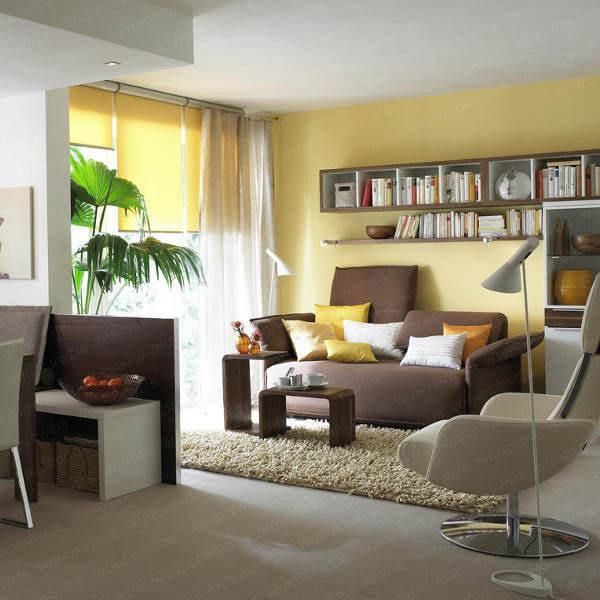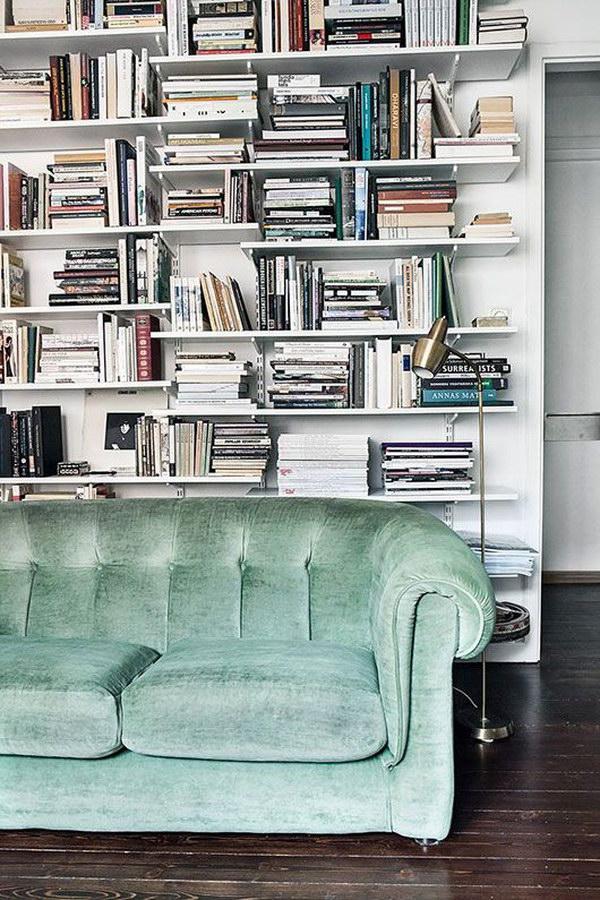The first image is the image on the left, the second image is the image on the right. Assess this claim about the two images: "A bookshelf sits behind a couch in a yellow room in one of the images.". Correct or not? Answer yes or no. Yes. The first image is the image on the left, the second image is the image on the right. For the images shown, is this caption "A tufted royal blue sofa is in front of a wall-filling bookcase that is not white." true? Answer yes or no. No. 